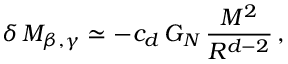<formula> <loc_0><loc_0><loc_500><loc_500>\delta \, M _ { \beta , \gamma } \simeq - c _ { d } \, G _ { N } \, \frac { M ^ { 2 } } { R ^ { d - 2 } } \, ,</formula> 